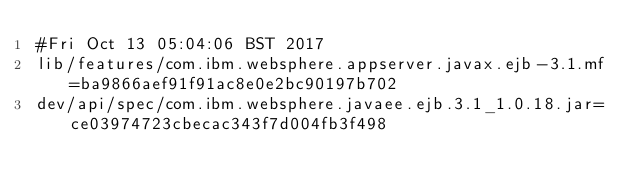<code> <loc_0><loc_0><loc_500><loc_500><_C#_>#Fri Oct 13 05:04:06 BST 2017
lib/features/com.ibm.websphere.appserver.javax.ejb-3.1.mf=ba9866aef91f91ac8e0e2bc90197b702
dev/api/spec/com.ibm.websphere.javaee.ejb.3.1_1.0.18.jar=ce03974723cbecac343f7d004fb3f498
</code> 